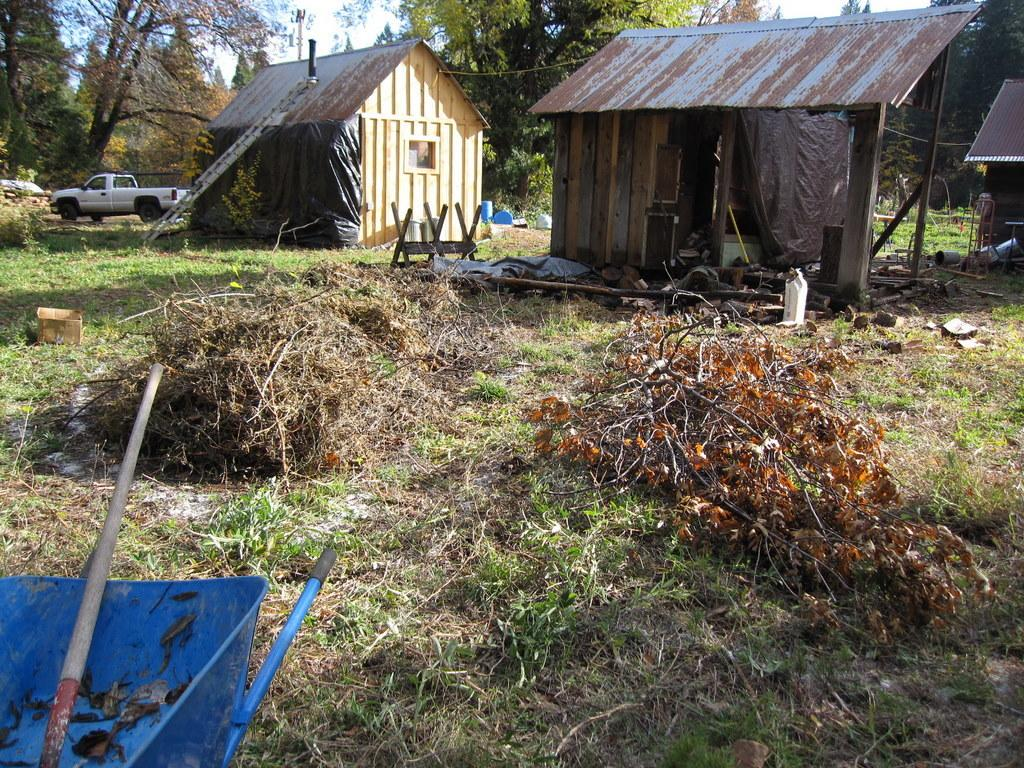What type of ground is visible in the image? There is a greenery ground in the image. What can be seen on the ground in the image? There are dried plants placed on the ground. What structures can be seen in the background of the image? There is a hut and a vehicle in the background of the image. What type of vegetation is visible in the background of the image? There are trees in the background of the image. What else can be seen in the background of the image? There are other objects present in the background of the image. What sound can be heard coming from the donkey in the image? There is no donkey present in the image, so no sound can be heard from a donkey. 